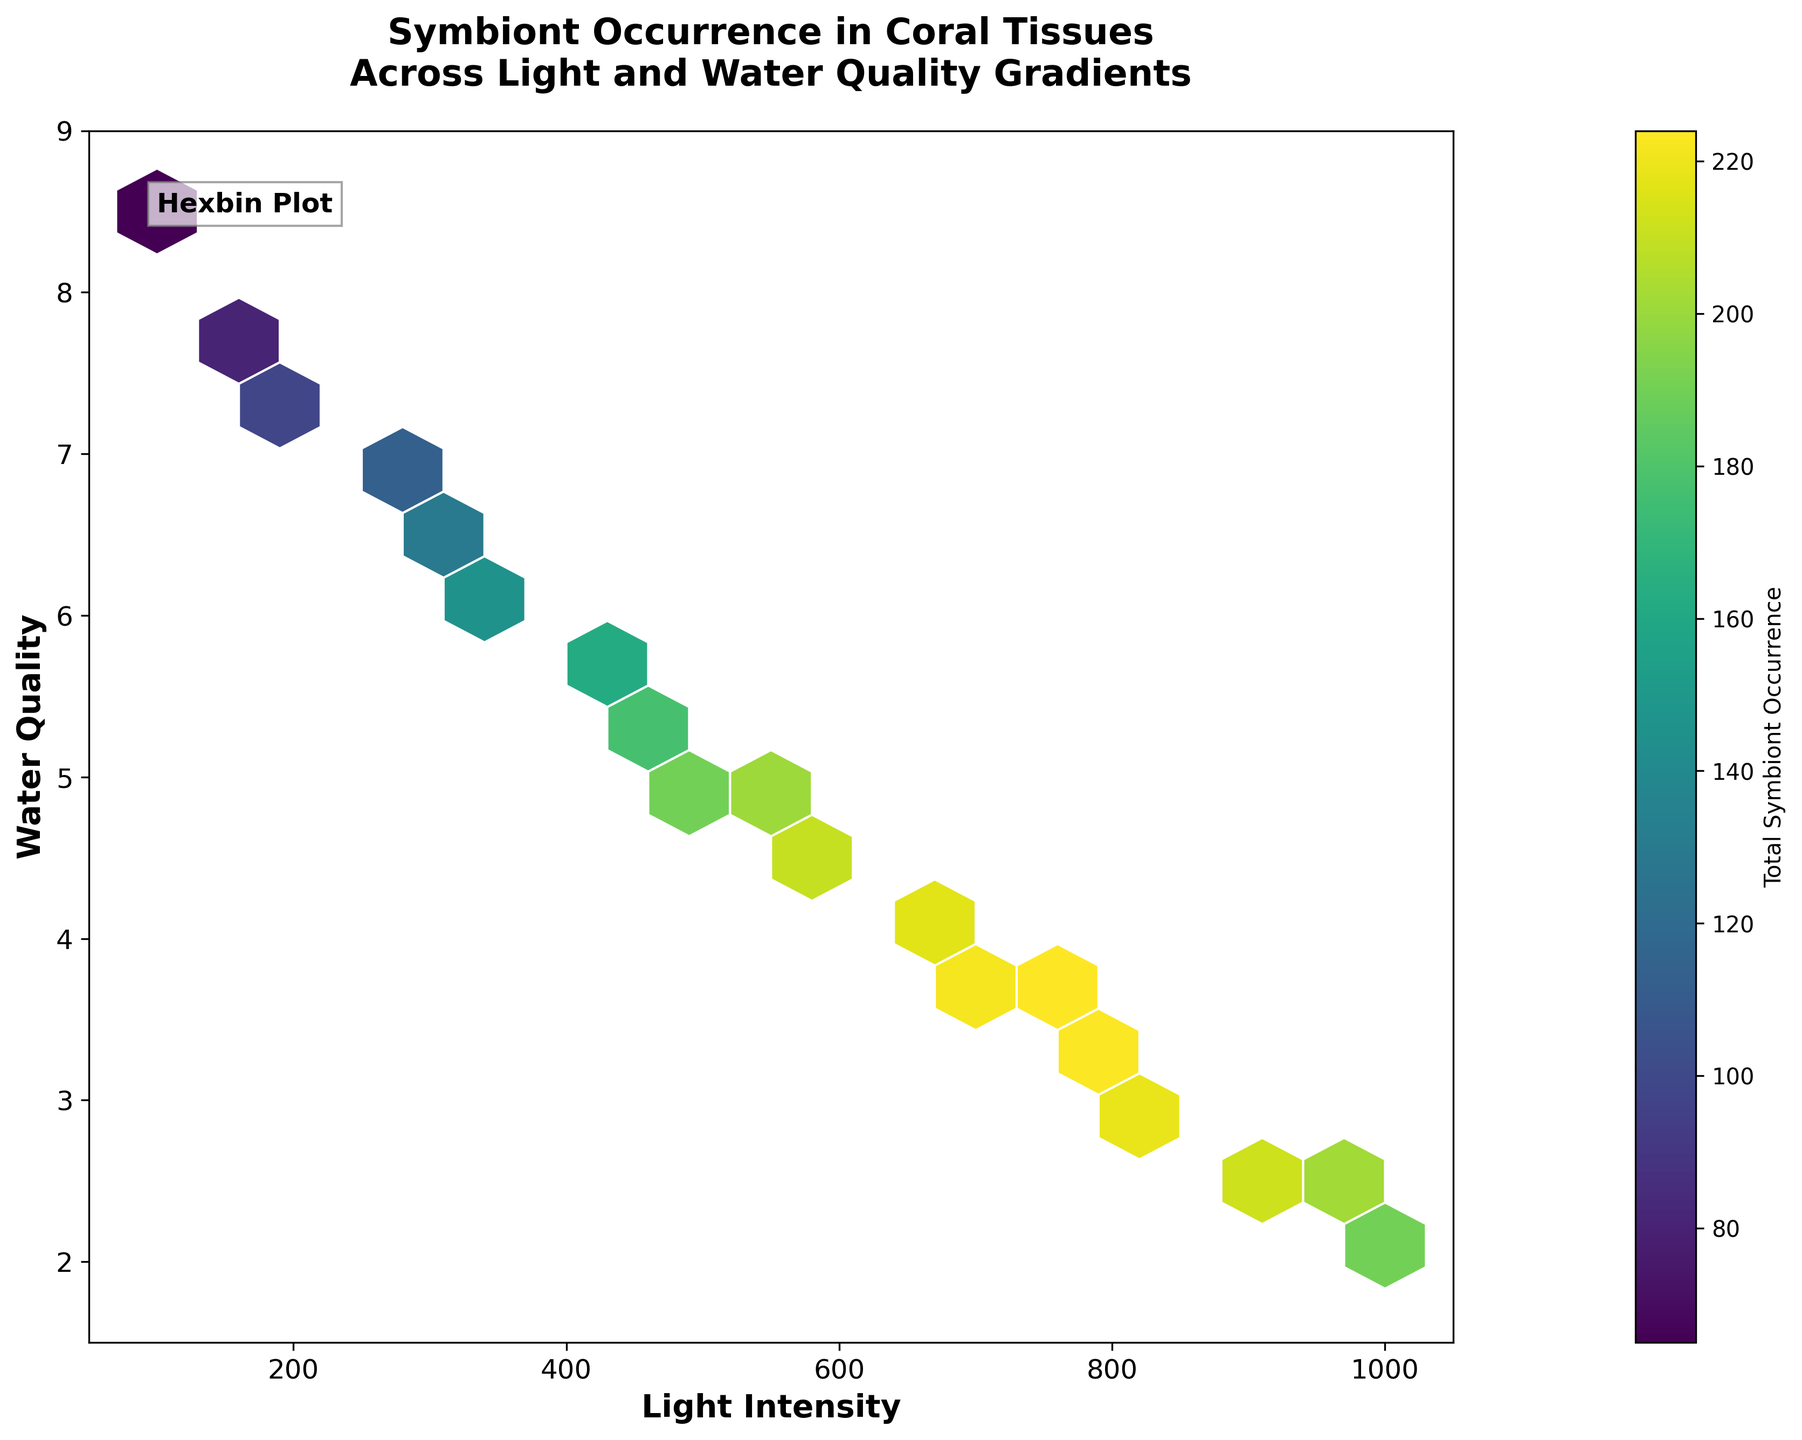What is the title of the figure? The title is located at the top of the plot and summarizes what the plot is about. It reads: 'Symbiont Occurrence in Coral Tissues Across Light and Water Quality Gradients'.
Answer: Symbiont Occurrence in Coral Tissues Across Light and Water Quality Gradients What do the axes on the plot represent? The x-axis label reads 'Light Intensity' and the y-axis label reads 'Water Quality'.
Answer: Light Intensity and Water Quality What color scheme is used for depicting the symbiont occurrence on the hexbin plot? The color scheme on the hexbin plot transitions through shades of the 'viridis' colormap, typically using colors ranging from blue to yellow.
Answer: Viridis (blue to yellow) Which light intensity and water quality combination has the highest total symbiont occurrence? The region of the hexbin plot with the most intense color indicates the highest symbiont occurrence. This appears around the light intensity of 500 and water quality of 5.1.
Answer: Light Intensity ~500, Water Quality ~5.1 How many data points are displayed in the hexbin plot? Since the plot uses a hexbin grid with hexagons, counting the number of distinct hexagons filled can give the total number of original data points. Each hexagon represents one or more overlapping data points. Therefore, the number of hexagons approximates 19 as there are 19 pairs of light intensity and water quality in the input data.
Answer: 19 Which clade has the highest representation at a light intensity of 750 and a water quality of 3.6? At the specified conditions, use the data to compare values for Symbiodinium clade C, Symbiodinium clade D, and Breviolum species. Clade D has the highest occurrence with 85 overlaps.
Answer: Symbiodinium clade D In which light intensity range do you see a sudden drop in water quality? Observing the y-axis and locating points where there's a sudden decrease, this occurs between the light intensities of 800 to 1000 where water quality drops from 3.3 to 2.1.
Answer: 800 to 1000 What trend do you observe between light intensity and water quality in relation to symbiont occurrence? By examining the plot, as light intensity increases, water quality decreases. However, symbiont occurrence peaks around moderate light intensities and average to lower water qualities (up to around 500 intensity and 5.1 quality). Beyond this point, occurrence gradually decreases.
Answer: Light intensity increases, water quality decreases, and symbiont occurrence peaks at moderate levels What hexagon grid size is used in the plot? The grid size can be inferred from the 'gridsize' parameter in hexbin functions or by visually estimating the density of hexagons. The plot appears to use a hexagon grid with a size of 15.
Answer: 15 